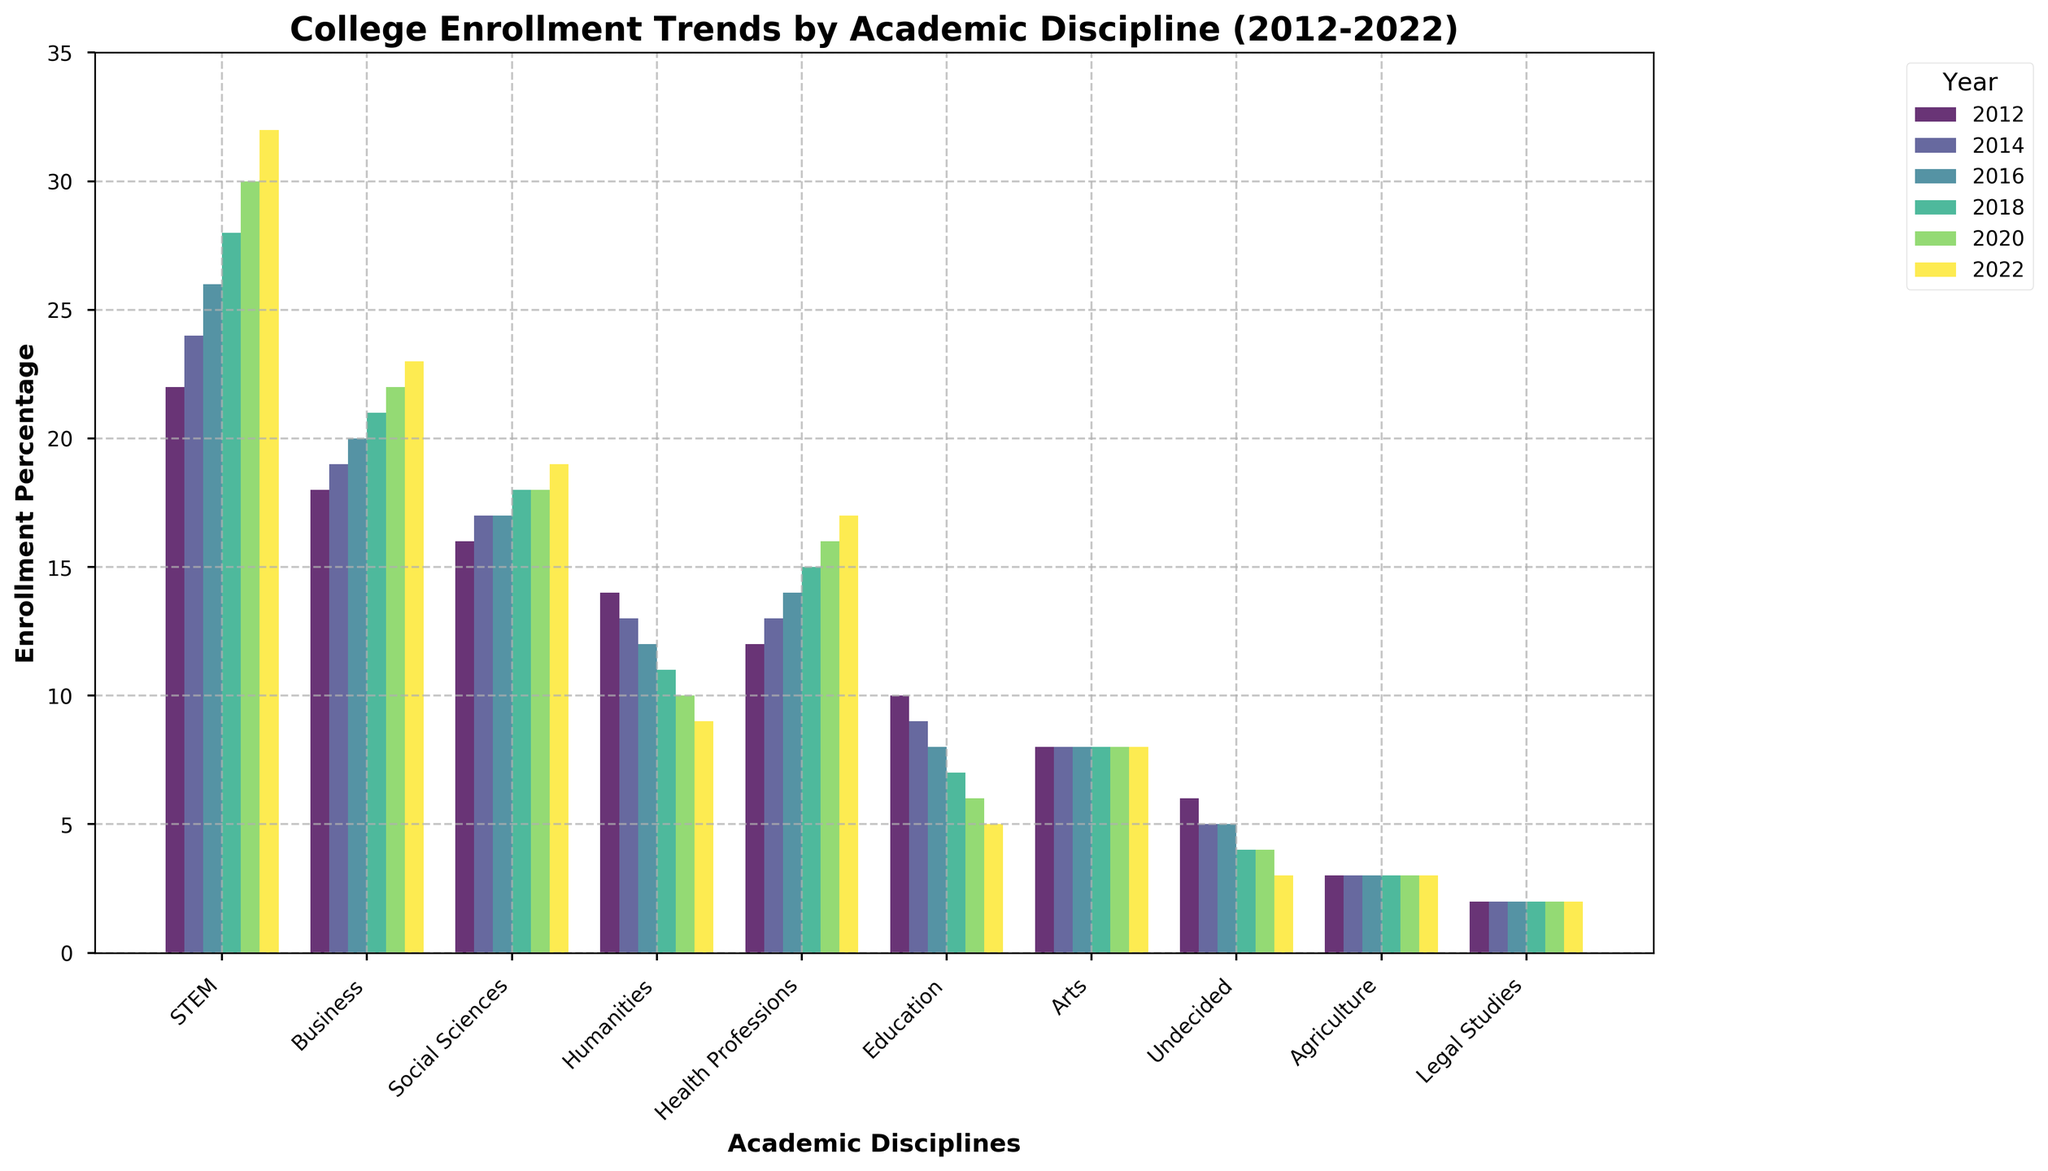Which academic disciplines increased in enrollment percentage over the decade? Look for the disciplines where the bars increase in height from 2012 to 2022. STEM, Business, Social Sciences, Health Professions, and Arts show an increasing trend.
Answer: STEM, Business, Social Sciences, Health Professions, Arts Which academic discipline saw the most consistent enrollment percentage over the decade? Compare the bars for each discipline across all years to identify which one shows little to no change. Agriculture has consistent bars of the same height across all years.
Answer: Agriculture What is the net change in enrollment percentage for Education from 2012 to 2022? Subtract the enrollment percentage in 2022 from that in 2012 for Education. Enrollment in Education in 2012 was 10%, and in 2022 it was 5%. 10 - 5 = 5
Answer: 5 Which academic discipline had the largest enrollment percentage in 2022? Look at the bars corresponding to 2022 and find the tallest one. The tallest bar in 2022 is STEM.
Answer: STEM How does the enrollment trend for Humanities compare to that of STEM over the decade? Compare the height of the bars for Humanities and STEM across the years. STEM consistently increased, while Humanities consistently decreased.
Answer: STEM increased, Humanities decreased By how much did the enrollment percentage for Social Sciences change from 2012 to 2018? Subtract the enrollment percentage in 2012 from that in 2018 for Social Sciences. Enrollment in Social Sciences in 2012 was 16%, and in 2018 it was 18%. 18 - 16 = 2
Answer: 2 Which academic discipline had the lowest enrollment percentage in 2020? Look at the bars corresponding to 2020 and find the shortest one. The shortest bar in 2020 is Legal Studies.
Answer: Legal Studies What is the average enrollment percentage for Business over the decade? Add all the enrollment percentages for Business across the years and divide by the number of data points. (18 + 19 + 20 + 21 + 22 + 23) = 123, 123 / 6 = 20.5
Answer: 20.5 